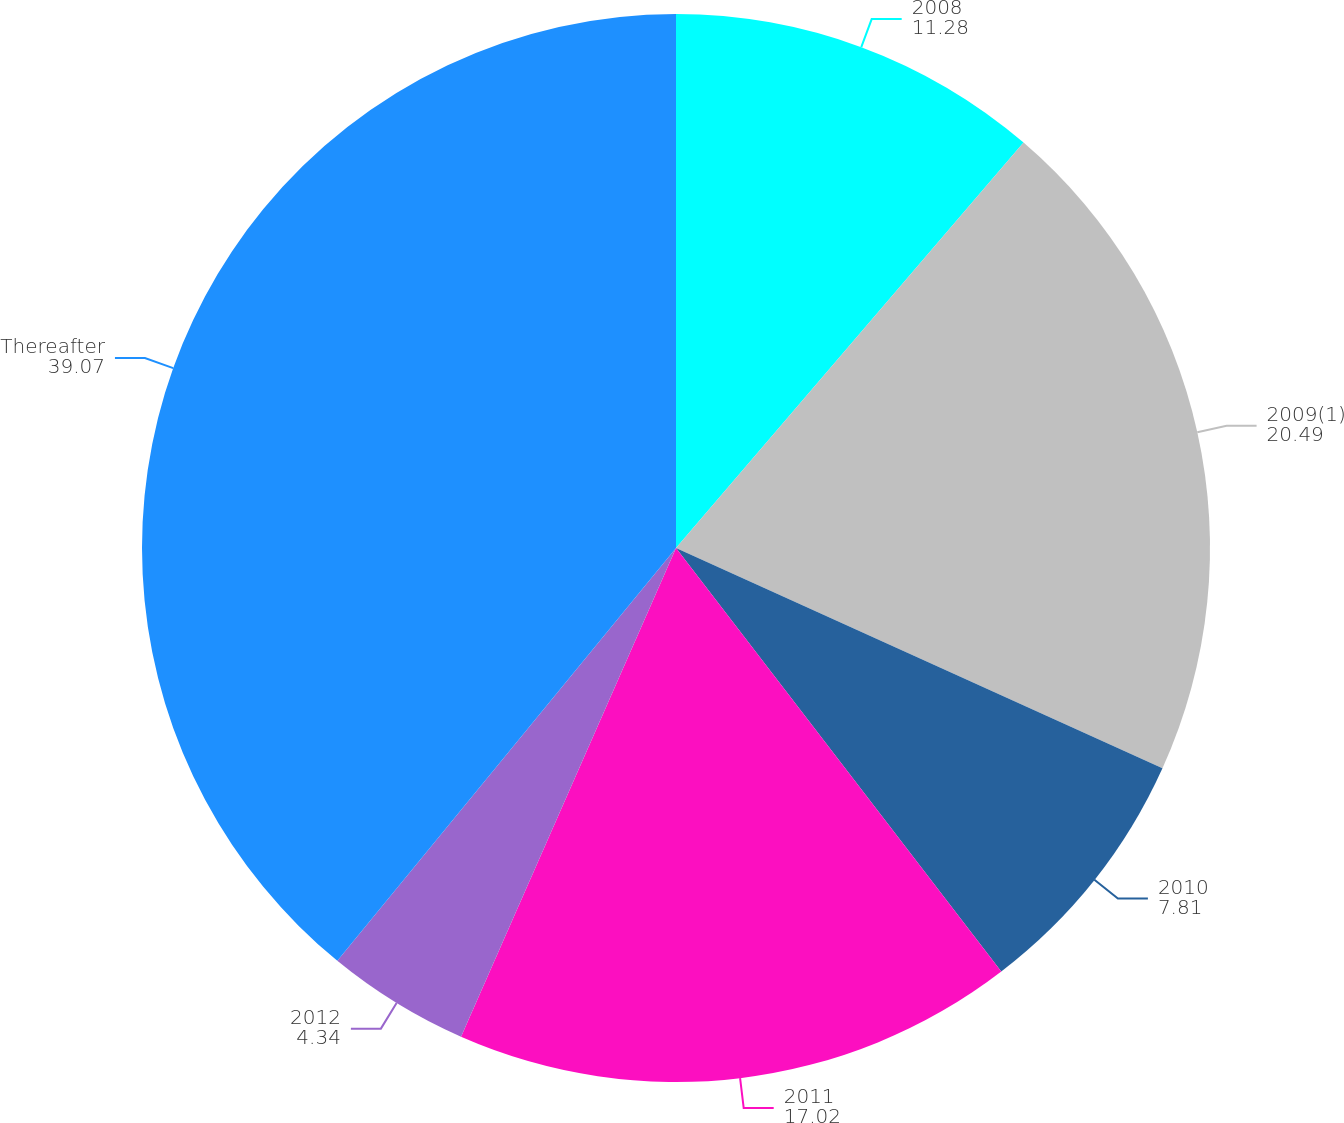<chart> <loc_0><loc_0><loc_500><loc_500><pie_chart><fcel>2008<fcel>2009(1)<fcel>2010<fcel>2011<fcel>2012<fcel>Thereafter<nl><fcel>11.28%<fcel>20.49%<fcel>7.81%<fcel>17.02%<fcel>4.34%<fcel>39.07%<nl></chart> 